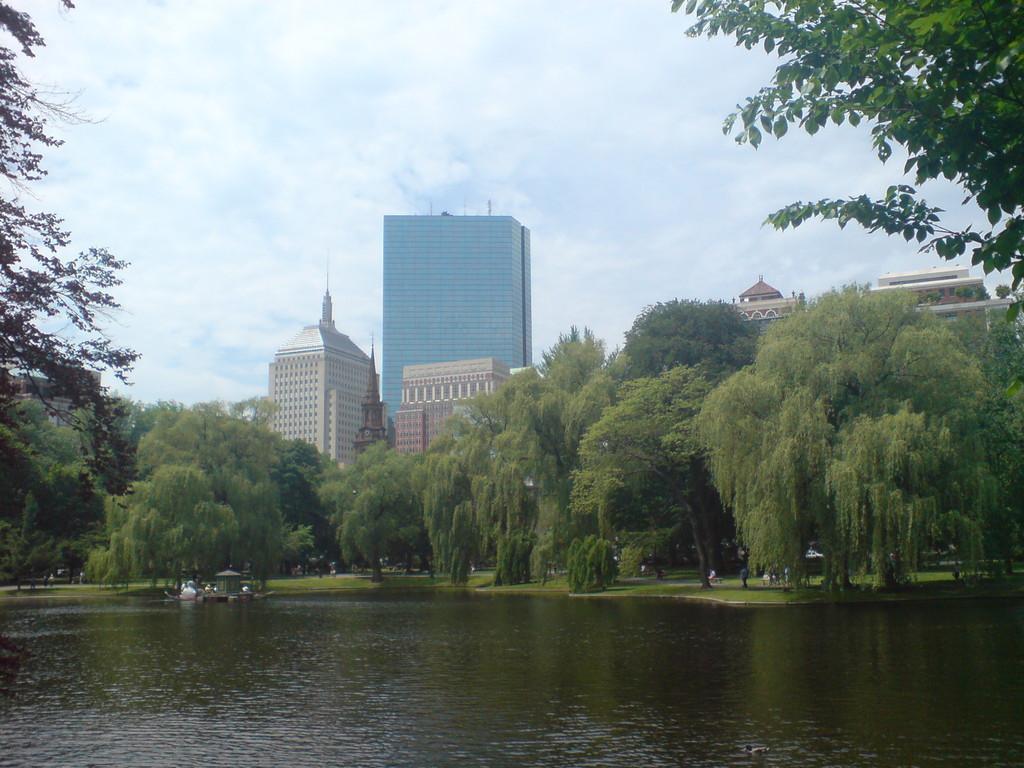How would you summarize this image in a sentence or two? In this image we can see some trees around the water and in the background, we can see some buildings and at the top there is a sky with clouds. 